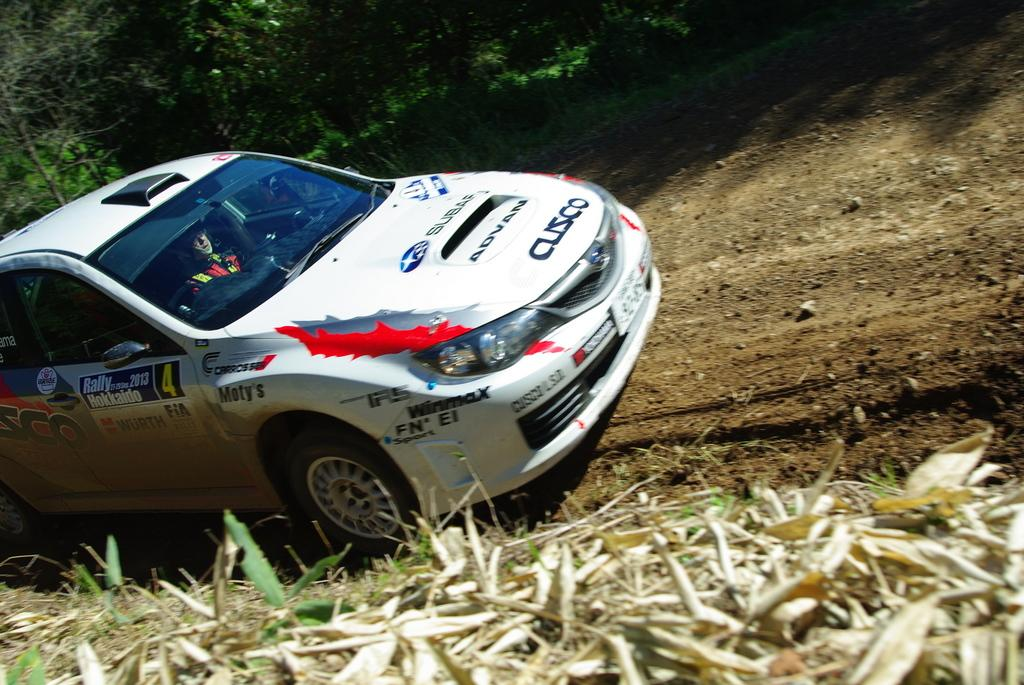What type of vegetation can be seen in the image? There are trees and plants in the image. What part of the vegetation is visible in the image? There are leaves in the image. Can you describe the person in the image? There is a person inside a car in the image. What is visible on the right side of the image? The ground is visible on the right side of the image. What type of chalk is the boy using to draw on the cloud in the image? There is no boy or cloud present in the image, and therefore no chalk or drawing activity can be observed. 